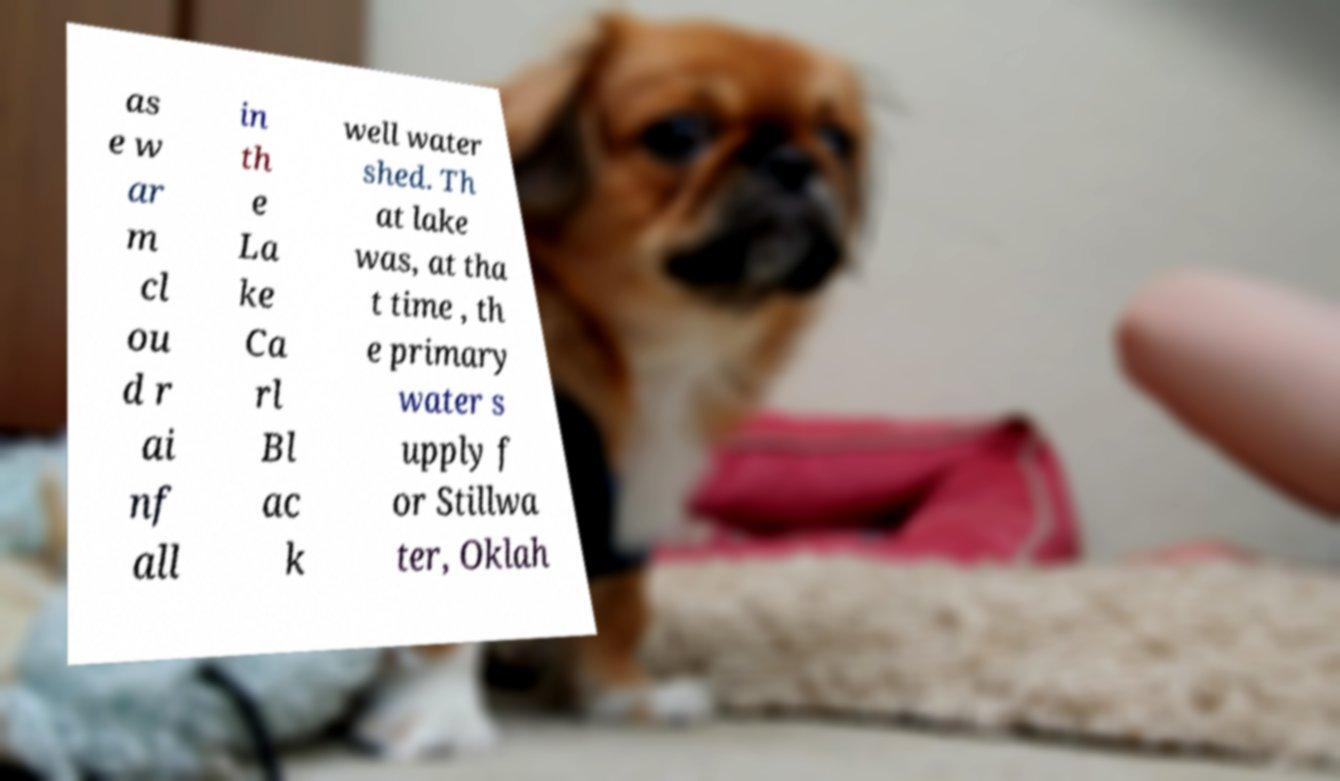Could you assist in decoding the text presented in this image and type it out clearly? as e w ar m cl ou d r ai nf all in th e La ke Ca rl Bl ac k well water shed. Th at lake was, at tha t time , th e primary water s upply f or Stillwa ter, Oklah 